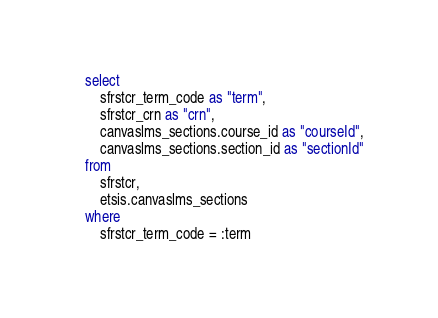<code> <loc_0><loc_0><loc_500><loc_500><_SQL_>select
    sfrstcr_term_code as "term",
    sfrstcr_crn as "crn",
    canvaslms_sections.course_id as "courseId",
    canvaslms_sections.section_id as "sectionId"
from
    sfrstcr,
    etsis.canvaslms_sections
where
    sfrstcr_term_code = :term</code> 